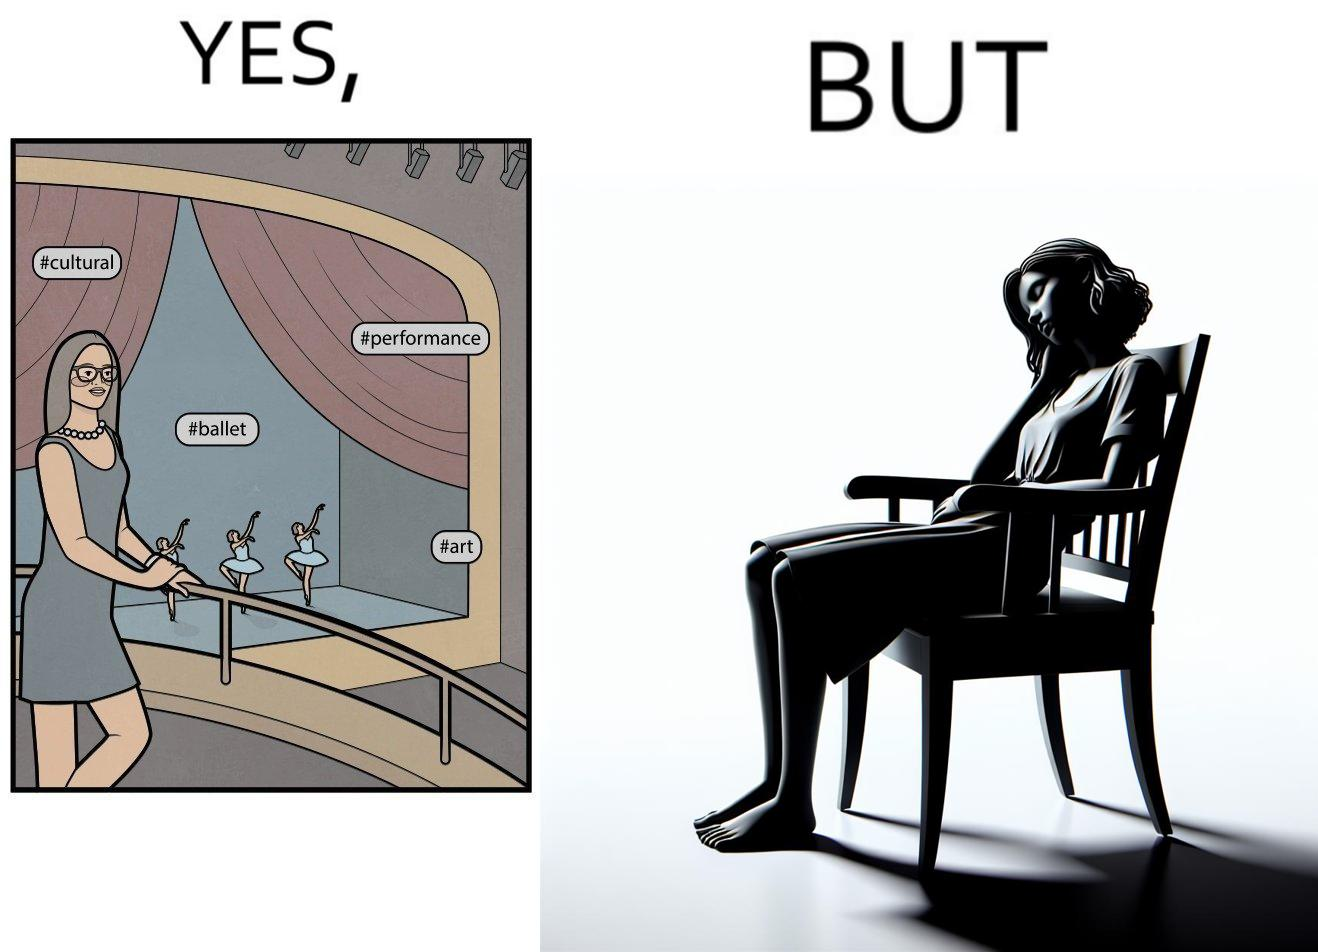Does this image contain satire or humor? Yes, this image is satirical. 